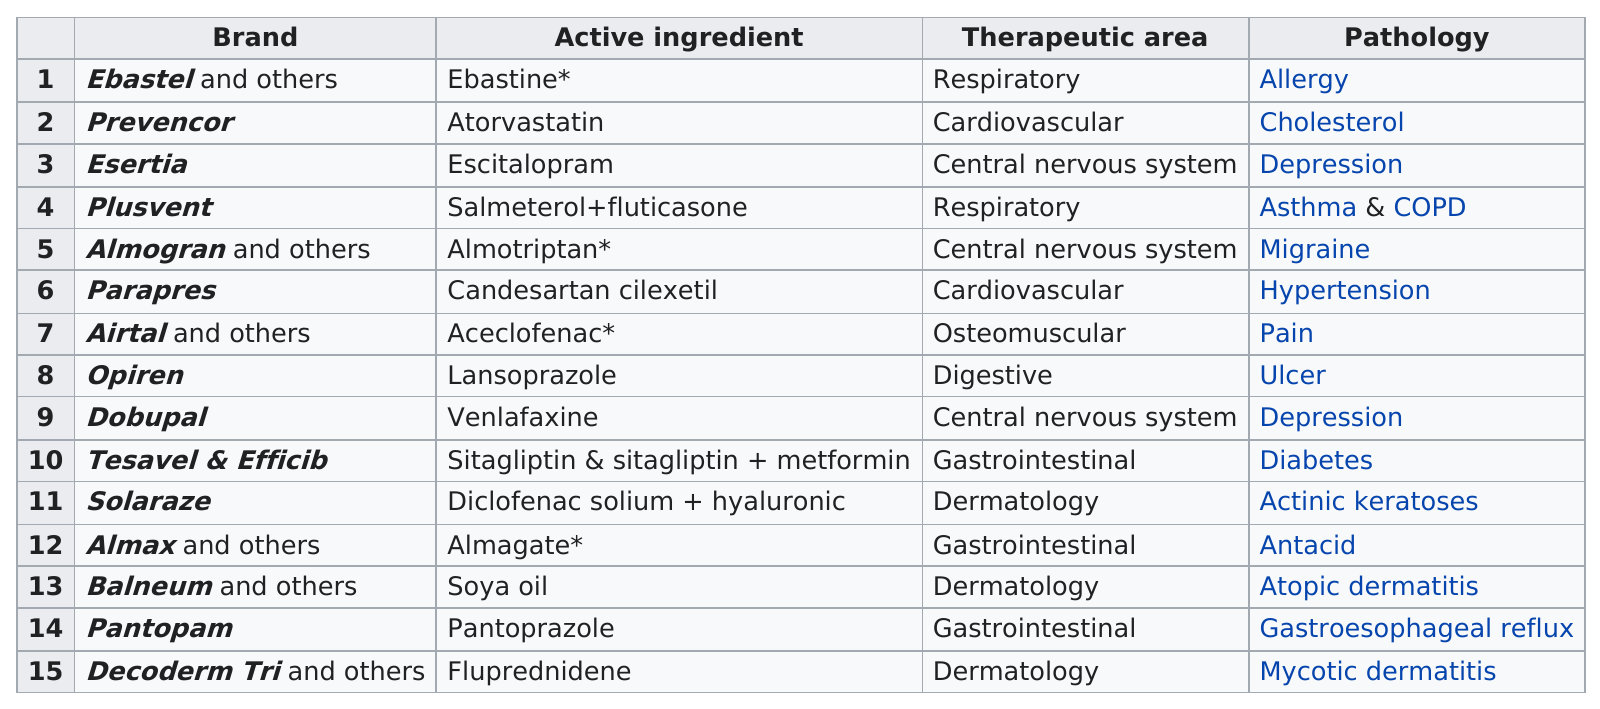List a handful of essential elements in this visual. According to recent data, three of the top-selling brands specifically target the dermatology market. Dobupal is the brand that comes next after Opiren. Dobupal is the next highest selling brand after Opren in terms of sales. There are two brands available for the treatment of depression. Two brands currently treat the respiratory system. 